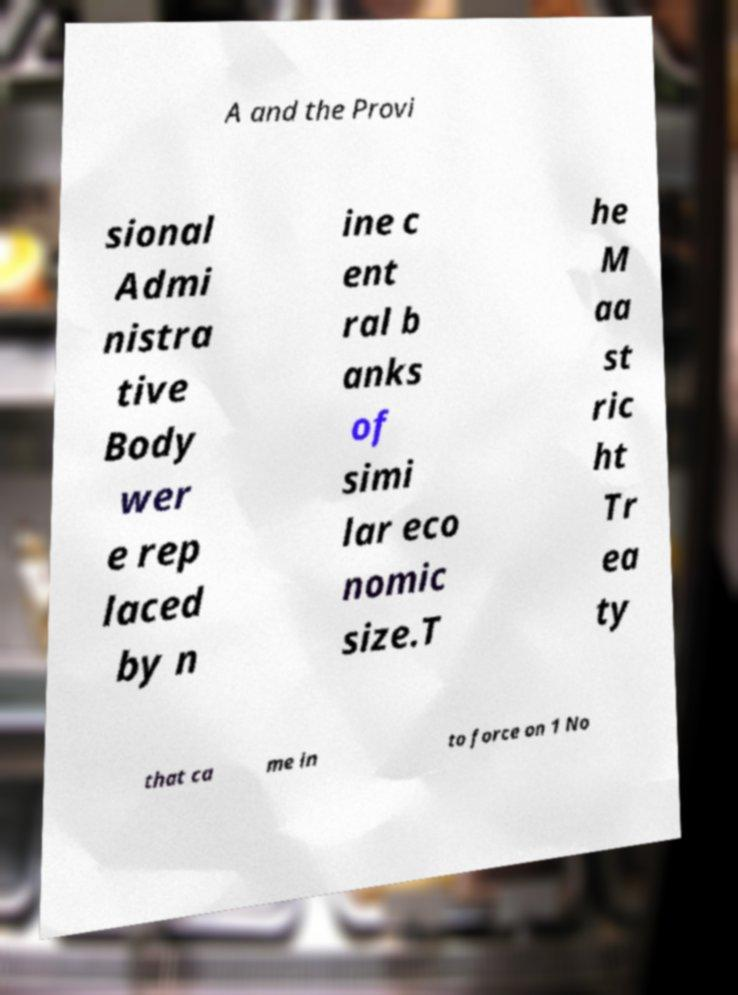There's text embedded in this image that I need extracted. Can you transcribe it verbatim? A and the Provi sional Admi nistra tive Body wer e rep laced by n ine c ent ral b anks of simi lar eco nomic size.T he M aa st ric ht Tr ea ty that ca me in to force on 1 No 